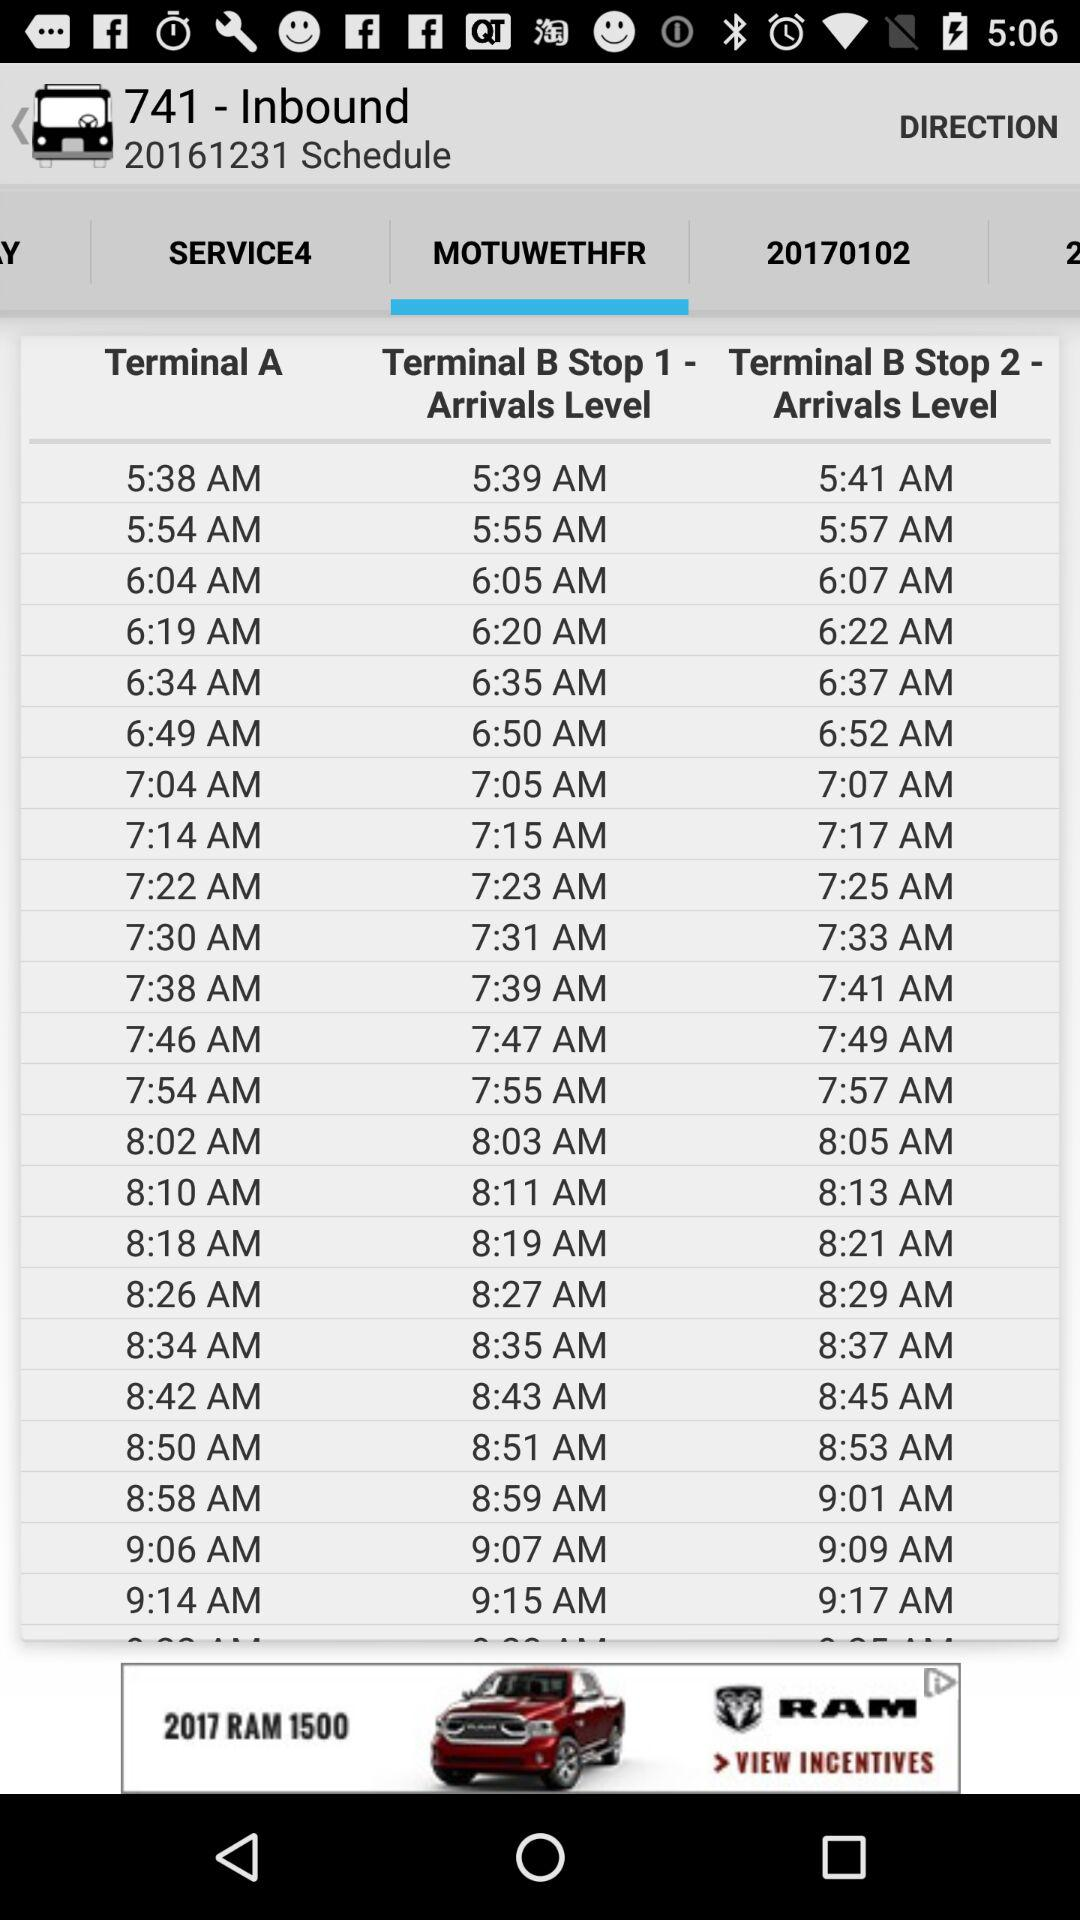Which tab has been selected? The tab that has been selected is "MOTUWETHFR". 